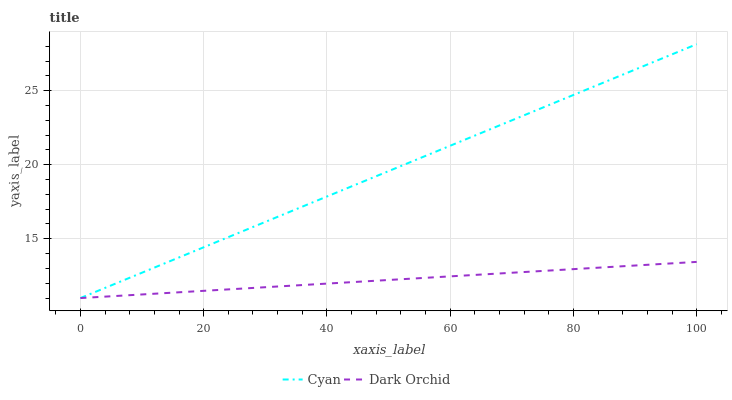Does Dark Orchid have the minimum area under the curve?
Answer yes or no. Yes. Does Cyan have the maximum area under the curve?
Answer yes or no. Yes. Does Dark Orchid have the maximum area under the curve?
Answer yes or no. No. Is Dark Orchid the smoothest?
Answer yes or no. Yes. Is Cyan the roughest?
Answer yes or no. Yes. Is Dark Orchid the roughest?
Answer yes or no. No. Does Cyan have the highest value?
Answer yes or no. Yes. Does Dark Orchid have the highest value?
Answer yes or no. No. 